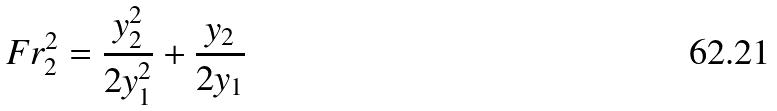Convert formula to latex. <formula><loc_0><loc_0><loc_500><loc_500>F r _ { 2 } ^ { 2 } = \frac { y _ { 2 } ^ { 2 } } { 2 y _ { 1 } ^ { 2 } } + \frac { y _ { 2 } } { 2 y _ { 1 } }</formula> 